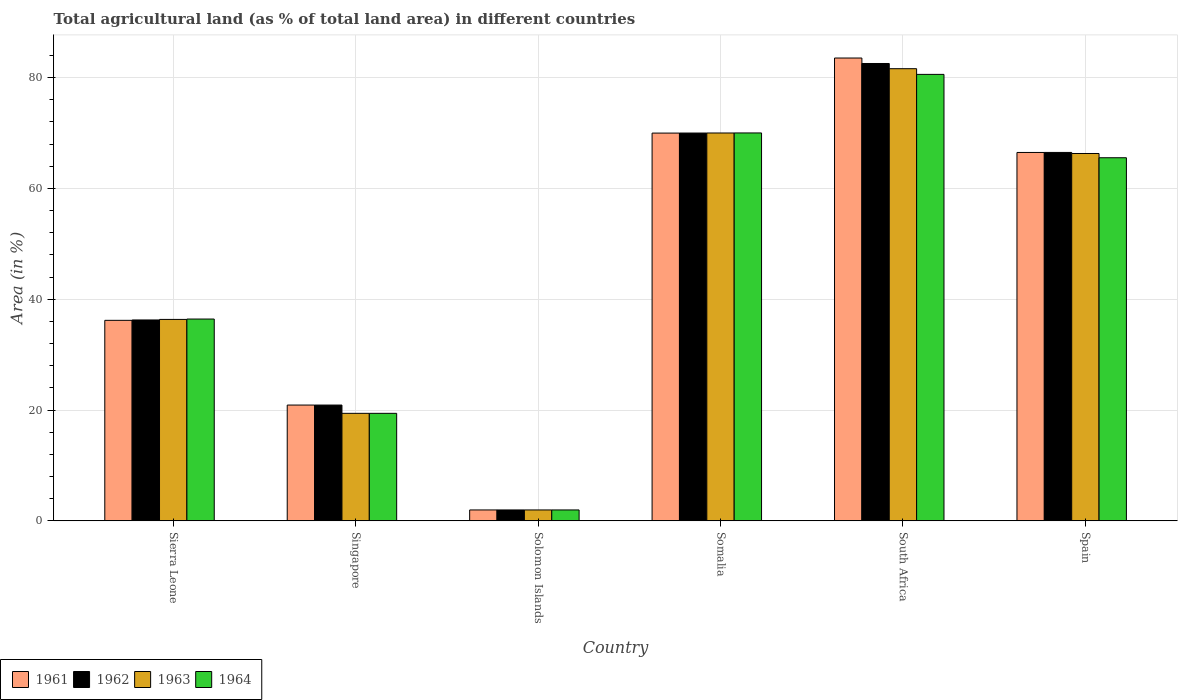How many different coloured bars are there?
Make the answer very short. 4. How many groups of bars are there?
Your answer should be very brief. 6. How many bars are there on the 4th tick from the left?
Provide a succinct answer. 4. How many bars are there on the 1st tick from the right?
Give a very brief answer. 4. What is the label of the 3rd group of bars from the left?
Your response must be concise. Solomon Islands. What is the percentage of agricultural land in 1964 in Singapore?
Give a very brief answer. 19.4. Across all countries, what is the maximum percentage of agricultural land in 1963?
Offer a terse response. 81.61. Across all countries, what is the minimum percentage of agricultural land in 1963?
Offer a terse response. 1.96. In which country was the percentage of agricultural land in 1964 maximum?
Offer a terse response. South Africa. In which country was the percentage of agricultural land in 1962 minimum?
Offer a very short reply. Solomon Islands. What is the total percentage of agricultural land in 1961 in the graph?
Provide a succinct answer. 279.06. What is the difference between the percentage of agricultural land in 1962 in Somalia and that in South Africa?
Offer a terse response. -12.55. What is the difference between the percentage of agricultural land in 1964 in South Africa and the percentage of agricultural land in 1962 in Sierra Leone?
Your response must be concise. 44.32. What is the average percentage of agricultural land in 1963 per country?
Your response must be concise. 45.94. In how many countries, is the percentage of agricultural land in 1964 greater than 48 %?
Your answer should be very brief. 3. What is the ratio of the percentage of agricultural land in 1962 in Sierra Leone to that in Solomon Islands?
Make the answer very short. 18.45. Is the percentage of agricultural land in 1964 in Sierra Leone less than that in South Africa?
Ensure brevity in your answer.  Yes. What is the difference between the highest and the second highest percentage of agricultural land in 1962?
Offer a terse response. 12.55. What is the difference between the highest and the lowest percentage of agricultural land in 1964?
Give a very brief answer. 78.61. In how many countries, is the percentage of agricultural land in 1962 greater than the average percentage of agricultural land in 1962 taken over all countries?
Offer a very short reply. 3. Is the sum of the percentage of agricultural land in 1963 in Singapore and South Africa greater than the maximum percentage of agricultural land in 1962 across all countries?
Give a very brief answer. Yes. Is it the case that in every country, the sum of the percentage of agricultural land in 1964 and percentage of agricultural land in 1963 is greater than the sum of percentage of agricultural land in 1961 and percentage of agricultural land in 1962?
Provide a short and direct response. No. What does the 3rd bar from the right in Somalia represents?
Your response must be concise. 1962. Is it the case that in every country, the sum of the percentage of agricultural land in 1961 and percentage of agricultural land in 1964 is greater than the percentage of agricultural land in 1963?
Give a very brief answer. Yes. How many bars are there?
Provide a succinct answer. 24. How many countries are there in the graph?
Make the answer very short. 6. Are the values on the major ticks of Y-axis written in scientific E-notation?
Keep it short and to the point. No. Does the graph contain any zero values?
Provide a succinct answer. No. Does the graph contain grids?
Your answer should be compact. Yes. Where does the legend appear in the graph?
Ensure brevity in your answer.  Bottom left. What is the title of the graph?
Offer a terse response. Total agricultural land (as % of total land area) in different countries. What is the label or title of the X-axis?
Ensure brevity in your answer.  Country. What is the label or title of the Y-axis?
Your answer should be compact. Area (in %). What is the Area (in %) in 1961 in Sierra Leone?
Provide a succinct answer. 36.19. What is the Area (in %) in 1962 in Sierra Leone?
Keep it short and to the point. 36.26. What is the Area (in %) in 1963 in Sierra Leone?
Keep it short and to the point. 36.35. What is the Area (in %) in 1964 in Sierra Leone?
Provide a succinct answer. 36.42. What is the Area (in %) in 1961 in Singapore?
Give a very brief answer. 20.9. What is the Area (in %) of 1962 in Singapore?
Your answer should be very brief. 20.9. What is the Area (in %) in 1963 in Singapore?
Make the answer very short. 19.4. What is the Area (in %) of 1964 in Singapore?
Keep it short and to the point. 19.4. What is the Area (in %) in 1961 in Solomon Islands?
Your answer should be very brief. 1.96. What is the Area (in %) in 1962 in Solomon Islands?
Offer a very short reply. 1.96. What is the Area (in %) in 1963 in Solomon Islands?
Ensure brevity in your answer.  1.96. What is the Area (in %) in 1964 in Solomon Islands?
Your response must be concise. 1.96. What is the Area (in %) in 1961 in Somalia?
Provide a short and direct response. 69.99. What is the Area (in %) of 1962 in Somalia?
Your answer should be compact. 69.99. What is the Area (in %) in 1963 in Somalia?
Your response must be concise. 70. What is the Area (in %) in 1964 in Somalia?
Provide a succinct answer. 70.01. What is the Area (in %) in 1961 in South Africa?
Give a very brief answer. 83.53. What is the Area (in %) in 1962 in South Africa?
Give a very brief answer. 82.55. What is the Area (in %) of 1963 in South Africa?
Make the answer very short. 81.61. What is the Area (in %) in 1964 in South Africa?
Give a very brief answer. 80.58. What is the Area (in %) of 1961 in Spain?
Offer a very short reply. 66.49. What is the Area (in %) of 1962 in Spain?
Offer a terse response. 66.49. What is the Area (in %) of 1963 in Spain?
Give a very brief answer. 66.3. What is the Area (in %) in 1964 in Spain?
Provide a succinct answer. 65.53. Across all countries, what is the maximum Area (in %) in 1961?
Your answer should be compact. 83.53. Across all countries, what is the maximum Area (in %) in 1962?
Make the answer very short. 82.55. Across all countries, what is the maximum Area (in %) in 1963?
Offer a terse response. 81.61. Across all countries, what is the maximum Area (in %) of 1964?
Make the answer very short. 80.58. Across all countries, what is the minimum Area (in %) of 1961?
Offer a terse response. 1.96. Across all countries, what is the minimum Area (in %) of 1962?
Your answer should be compact. 1.96. Across all countries, what is the minimum Area (in %) in 1963?
Provide a short and direct response. 1.96. Across all countries, what is the minimum Area (in %) of 1964?
Ensure brevity in your answer.  1.96. What is the total Area (in %) in 1961 in the graph?
Provide a short and direct response. 279.06. What is the total Area (in %) of 1962 in the graph?
Make the answer very short. 278.15. What is the total Area (in %) of 1963 in the graph?
Make the answer very short. 275.63. What is the total Area (in %) of 1964 in the graph?
Offer a terse response. 273.91. What is the difference between the Area (in %) in 1961 in Sierra Leone and that in Singapore?
Give a very brief answer. 15.29. What is the difference between the Area (in %) of 1962 in Sierra Leone and that in Singapore?
Your answer should be very brief. 15.36. What is the difference between the Area (in %) in 1963 in Sierra Leone and that in Singapore?
Your response must be concise. 16.95. What is the difference between the Area (in %) of 1964 in Sierra Leone and that in Singapore?
Your answer should be very brief. 17.02. What is the difference between the Area (in %) of 1961 in Sierra Leone and that in Solomon Islands?
Your answer should be very brief. 34.22. What is the difference between the Area (in %) of 1962 in Sierra Leone and that in Solomon Islands?
Your answer should be compact. 34.29. What is the difference between the Area (in %) of 1963 in Sierra Leone and that in Solomon Islands?
Your answer should be compact. 34.39. What is the difference between the Area (in %) in 1964 in Sierra Leone and that in Solomon Islands?
Make the answer very short. 34.46. What is the difference between the Area (in %) in 1961 in Sierra Leone and that in Somalia?
Make the answer very short. -33.8. What is the difference between the Area (in %) in 1962 in Sierra Leone and that in Somalia?
Your answer should be compact. -33.74. What is the difference between the Area (in %) in 1963 in Sierra Leone and that in Somalia?
Provide a succinct answer. -33.65. What is the difference between the Area (in %) of 1964 in Sierra Leone and that in Somalia?
Your answer should be compact. -33.59. What is the difference between the Area (in %) of 1961 in Sierra Leone and that in South Africa?
Offer a very short reply. -47.35. What is the difference between the Area (in %) in 1962 in Sierra Leone and that in South Africa?
Ensure brevity in your answer.  -46.29. What is the difference between the Area (in %) of 1963 in Sierra Leone and that in South Africa?
Offer a very short reply. -45.25. What is the difference between the Area (in %) in 1964 in Sierra Leone and that in South Africa?
Provide a short and direct response. -44.16. What is the difference between the Area (in %) of 1961 in Sierra Leone and that in Spain?
Provide a succinct answer. -30.3. What is the difference between the Area (in %) in 1962 in Sierra Leone and that in Spain?
Offer a terse response. -30.24. What is the difference between the Area (in %) of 1963 in Sierra Leone and that in Spain?
Give a very brief answer. -29.95. What is the difference between the Area (in %) of 1964 in Sierra Leone and that in Spain?
Provide a short and direct response. -29.11. What is the difference between the Area (in %) of 1961 in Singapore and that in Solomon Islands?
Your response must be concise. 18.93. What is the difference between the Area (in %) in 1962 in Singapore and that in Solomon Islands?
Offer a very short reply. 18.93. What is the difference between the Area (in %) of 1963 in Singapore and that in Solomon Islands?
Give a very brief answer. 17.44. What is the difference between the Area (in %) of 1964 in Singapore and that in Solomon Islands?
Make the answer very short. 17.44. What is the difference between the Area (in %) of 1961 in Singapore and that in Somalia?
Give a very brief answer. -49.09. What is the difference between the Area (in %) of 1962 in Singapore and that in Somalia?
Your answer should be compact. -49.1. What is the difference between the Area (in %) in 1963 in Singapore and that in Somalia?
Your answer should be compact. -50.6. What is the difference between the Area (in %) in 1964 in Singapore and that in Somalia?
Keep it short and to the point. -50.61. What is the difference between the Area (in %) of 1961 in Singapore and that in South Africa?
Your answer should be very brief. -62.64. What is the difference between the Area (in %) in 1962 in Singapore and that in South Africa?
Keep it short and to the point. -61.65. What is the difference between the Area (in %) in 1963 in Singapore and that in South Africa?
Your answer should be very brief. -62.2. What is the difference between the Area (in %) in 1964 in Singapore and that in South Africa?
Offer a terse response. -61.18. What is the difference between the Area (in %) of 1961 in Singapore and that in Spain?
Your answer should be very brief. -45.59. What is the difference between the Area (in %) of 1962 in Singapore and that in Spain?
Provide a succinct answer. -45.6. What is the difference between the Area (in %) in 1963 in Singapore and that in Spain?
Offer a terse response. -46.9. What is the difference between the Area (in %) in 1964 in Singapore and that in Spain?
Give a very brief answer. -46.13. What is the difference between the Area (in %) of 1961 in Solomon Islands and that in Somalia?
Your answer should be very brief. -68.02. What is the difference between the Area (in %) in 1962 in Solomon Islands and that in Somalia?
Your answer should be very brief. -68.03. What is the difference between the Area (in %) in 1963 in Solomon Islands and that in Somalia?
Give a very brief answer. -68.04. What is the difference between the Area (in %) in 1964 in Solomon Islands and that in Somalia?
Your response must be concise. -68.04. What is the difference between the Area (in %) of 1961 in Solomon Islands and that in South Africa?
Give a very brief answer. -81.57. What is the difference between the Area (in %) of 1962 in Solomon Islands and that in South Africa?
Give a very brief answer. -80.58. What is the difference between the Area (in %) in 1963 in Solomon Islands and that in South Africa?
Make the answer very short. -79.64. What is the difference between the Area (in %) of 1964 in Solomon Islands and that in South Africa?
Provide a short and direct response. -78.61. What is the difference between the Area (in %) in 1961 in Solomon Islands and that in Spain?
Provide a succinct answer. -64.52. What is the difference between the Area (in %) of 1962 in Solomon Islands and that in Spain?
Ensure brevity in your answer.  -64.53. What is the difference between the Area (in %) in 1963 in Solomon Islands and that in Spain?
Ensure brevity in your answer.  -64.34. What is the difference between the Area (in %) of 1964 in Solomon Islands and that in Spain?
Make the answer very short. -63.57. What is the difference between the Area (in %) of 1961 in Somalia and that in South Africa?
Your answer should be very brief. -13.55. What is the difference between the Area (in %) of 1962 in Somalia and that in South Africa?
Provide a succinct answer. -12.55. What is the difference between the Area (in %) of 1963 in Somalia and that in South Africa?
Offer a terse response. -11.6. What is the difference between the Area (in %) in 1964 in Somalia and that in South Africa?
Offer a very short reply. -10.57. What is the difference between the Area (in %) in 1961 in Somalia and that in Spain?
Ensure brevity in your answer.  3.5. What is the difference between the Area (in %) in 1962 in Somalia and that in Spain?
Offer a very short reply. 3.5. What is the difference between the Area (in %) in 1963 in Somalia and that in Spain?
Your answer should be very brief. 3.7. What is the difference between the Area (in %) in 1964 in Somalia and that in Spain?
Offer a very short reply. 4.47. What is the difference between the Area (in %) in 1961 in South Africa and that in Spain?
Provide a succinct answer. 17.05. What is the difference between the Area (in %) in 1962 in South Africa and that in Spain?
Make the answer very short. 16.05. What is the difference between the Area (in %) in 1963 in South Africa and that in Spain?
Make the answer very short. 15.3. What is the difference between the Area (in %) of 1964 in South Africa and that in Spain?
Keep it short and to the point. 15.04. What is the difference between the Area (in %) of 1961 in Sierra Leone and the Area (in %) of 1962 in Singapore?
Provide a succinct answer. 15.29. What is the difference between the Area (in %) in 1961 in Sierra Leone and the Area (in %) in 1963 in Singapore?
Provide a short and direct response. 16.78. What is the difference between the Area (in %) of 1961 in Sierra Leone and the Area (in %) of 1964 in Singapore?
Keep it short and to the point. 16.78. What is the difference between the Area (in %) of 1962 in Sierra Leone and the Area (in %) of 1963 in Singapore?
Ensure brevity in your answer.  16.85. What is the difference between the Area (in %) in 1962 in Sierra Leone and the Area (in %) in 1964 in Singapore?
Provide a succinct answer. 16.85. What is the difference between the Area (in %) in 1963 in Sierra Leone and the Area (in %) in 1964 in Singapore?
Give a very brief answer. 16.95. What is the difference between the Area (in %) of 1961 in Sierra Leone and the Area (in %) of 1962 in Solomon Islands?
Offer a very short reply. 34.22. What is the difference between the Area (in %) in 1961 in Sierra Leone and the Area (in %) in 1963 in Solomon Islands?
Keep it short and to the point. 34.22. What is the difference between the Area (in %) in 1961 in Sierra Leone and the Area (in %) in 1964 in Solomon Islands?
Give a very brief answer. 34.22. What is the difference between the Area (in %) in 1962 in Sierra Leone and the Area (in %) in 1963 in Solomon Islands?
Keep it short and to the point. 34.29. What is the difference between the Area (in %) in 1962 in Sierra Leone and the Area (in %) in 1964 in Solomon Islands?
Offer a very short reply. 34.29. What is the difference between the Area (in %) in 1963 in Sierra Leone and the Area (in %) in 1964 in Solomon Islands?
Make the answer very short. 34.39. What is the difference between the Area (in %) of 1961 in Sierra Leone and the Area (in %) of 1962 in Somalia?
Give a very brief answer. -33.81. What is the difference between the Area (in %) in 1961 in Sierra Leone and the Area (in %) in 1963 in Somalia?
Make the answer very short. -33.81. What is the difference between the Area (in %) in 1961 in Sierra Leone and the Area (in %) in 1964 in Somalia?
Provide a succinct answer. -33.82. What is the difference between the Area (in %) of 1962 in Sierra Leone and the Area (in %) of 1963 in Somalia?
Provide a succinct answer. -33.75. What is the difference between the Area (in %) of 1962 in Sierra Leone and the Area (in %) of 1964 in Somalia?
Give a very brief answer. -33.75. What is the difference between the Area (in %) of 1963 in Sierra Leone and the Area (in %) of 1964 in Somalia?
Provide a succinct answer. -33.66. What is the difference between the Area (in %) of 1961 in Sierra Leone and the Area (in %) of 1962 in South Africa?
Give a very brief answer. -46.36. What is the difference between the Area (in %) of 1961 in Sierra Leone and the Area (in %) of 1963 in South Africa?
Offer a terse response. -45.42. What is the difference between the Area (in %) of 1961 in Sierra Leone and the Area (in %) of 1964 in South Africa?
Your answer should be compact. -44.39. What is the difference between the Area (in %) of 1962 in Sierra Leone and the Area (in %) of 1963 in South Africa?
Your answer should be very brief. -45.35. What is the difference between the Area (in %) in 1962 in Sierra Leone and the Area (in %) in 1964 in South Africa?
Your answer should be compact. -44.32. What is the difference between the Area (in %) of 1963 in Sierra Leone and the Area (in %) of 1964 in South Africa?
Offer a very short reply. -44.23. What is the difference between the Area (in %) of 1961 in Sierra Leone and the Area (in %) of 1962 in Spain?
Provide a short and direct response. -30.31. What is the difference between the Area (in %) in 1961 in Sierra Leone and the Area (in %) in 1963 in Spain?
Provide a short and direct response. -30.12. What is the difference between the Area (in %) in 1961 in Sierra Leone and the Area (in %) in 1964 in Spain?
Offer a very short reply. -29.35. What is the difference between the Area (in %) in 1962 in Sierra Leone and the Area (in %) in 1963 in Spain?
Offer a very short reply. -30.05. What is the difference between the Area (in %) of 1962 in Sierra Leone and the Area (in %) of 1964 in Spain?
Your answer should be very brief. -29.28. What is the difference between the Area (in %) in 1963 in Sierra Leone and the Area (in %) in 1964 in Spain?
Offer a very short reply. -29.18. What is the difference between the Area (in %) in 1961 in Singapore and the Area (in %) in 1962 in Solomon Islands?
Provide a short and direct response. 18.93. What is the difference between the Area (in %) of 1961 in Singapore and the Area (in %) of 1963 in Solomon Islands?
Your answer should be compact. 18.93. What is the difference between the Area (in %) of 1961 in Singapore and the Area (in %) of 1964 in Solomon Islands?
Make the answer very short. 18.93. What is the difference between the Area (in %) of 1962 in Singapore and the Area (in %) of 1963 in Solomon Islands?
Your response must be concise. 18.93. What is the difference between the Area (in %) of 1962 in Singapore and the Area (in %) of 1964 in Solomon Islands?
Keep it short and to the point. 18.93. What is the difference between the Area (in %) in 1963 in Singapore and the Area (in %) in 1964 in Solomon Islands?
Provide a succinct answer. 17.44. What is the difference between the Area (in %) in 1961 in Singapore and the Area (in %) in 1962 in Somalia?
Provide a short and direct response. -49.1. What is the difference between the Area (in %) of 1961 in Singapore and the Area (in %) of 1963 in Somalia?
Ensure brevity in your answer.  -49.11. What is the difference between the Area (in %) in 1961 in Singapore and the Area (in %) in 1964 in Somalia?
Provide a short and direct response. -49.11. What is the difference between the Area (in %) of 1962 in Singapore and the Area (in %) of 1963 in Somalia?
Offer a very short reply. -49.11. What is the difference between the Area (in %) of 1962 in Singapore and the Area (in %) of 1964 in Somalia?
Your response must be concise. -49.11. What is the difference between the Area (in %) of 1963 in Singapore and the Area (in %) of 1964 in Somalia?
Offer a very short reply. -50.61. What is the difference between the Area (in %) of 1961 in Singapore and the Area (in %) of 1962 in South Africa?
Provide a succinct answer. -61.65. What is the difference between the Area (in %) of 1961 in Singapore and the Area (in %) of 1963 in South Africa?
Provide a short and direct response. -60.71. What is the difference between the Area (in %) in 1961 in Singapore and the Area (in %) in 1964 in South Africa?
Provide a succinct answer. -59.68. What is the difference between the Area (in %) in 1962 in Singapore and the Area (in %) in 1963 in South Africa?
Provide a short and direct response. -60.71. What is the difference between the Area (in %) of 1962 in Singapore and the Area (in %) of 1964 in South Africa?
Ensure brevity in your answer.  -59.68. What is the difference between the Area (in %) of 1963 in Singapore and the Area (in %) of 1964 in South Africa?
Ensure brevity in your answer.  -61.18. What is the difference between the Area (in %) of 1961 in Singapore and the Area (in %) of 1962 in Spain?
Offer a terse response. -45.6. What is the difference between the Area (in %) in 1961 in Singapore and the Area (in %) in 1963 in Spain?
Offer a terse response. -45.41. What is the difference between the Area (in %) in 1961 in Singapore and the Area (in %) in 1964 in Spain?
Provide a short and direct response. -44.64. What is the difference between the Area (in %) of 1962 in Singapore and the Area (in %) of 1963 in Spain?
Make the answer very short. -45.41. What is the difference between the Area (in %) in 1962 in Singapore and the Area (in %) in 1964 in Spain?
Offer a terse response. -44.64. What is the difference between the Area (in %) in 1963 in Singapore and the Area (in %) in 1964 in Spain?
Keep it short and to the point. -46.13. What is the difference between the Area (in %) of 1961 in Solomon Islands and the Area (in %) of 1962 in Somalia?
Offer a very short reply. -68.03. What is the difference between the Area (in %) in 1961 in Solomon Islands and the Area (in %) in 1963 in Somalia?
Ensure brevity in your answer.  -68.04. What is the difference between the Area (in %) in 1961 in Solomon Islands and the Area (in %) in 1964 in Somalia?
Your answer should be very brief. -68.04. What is the difference between the Area (in %) in 1962 in Solomon Islands and the Area (in %) in 1963 in Somalia?
Your response must be concise. -68.04. What is the difference between the Area (in %) in 1962 in Solomon Islands and the Area (in %) in 1964 in Somalia?
Ensure brevity in your answer.  -68.04. What is the difference between the Area (in %) of 1963 in Solomon Islands and the Area (in %) of 1964 in Somalia?
Provide a succinct answer. -68.04. What is the difference between the Area (in %) in 1961 in Solomon Islands and the Area (in %) in 1962 in South Africa?
Make the answer very short. -80.58. What is the difference between the Area (in %) of 1961 in Solomon Islands and the Area (in %) of 1963 in South Africa?
Keep it short and to the point. -79.64. What is the difference between the Area (in %) of 1961 in Solomon Islands and the Area (in %) of 1964 in South Africa?
Keep it short and to the point. -78.61. What is the difference between the Area (in %) of 1962 in Solomon Islands and the Area (in %) of 1963 in South Africa?
Offer a terse response. -79.64. What is the difference between the Area (in %) of 1962 in Solomon Islands and the Area (in %) of 1964 in South Africa?
Offer a very short reply. -78.61. What is the difference between the Area (in %) of 1963 in Solomon Islands and the Area (in %) of 1964 in South Africa?
Your answer should be compact. -78.61. What is the difference between the Area (in %) of 1961 in Solomon Islands and the Area (in %) of 1962 in Spain?
Keep it short and to the point. -64.53. What is the difference between the Area (in %) of 1961 in Solomon Islands and the Area (in %) of 1963 in Spain?
Your response must be concise. -64.34. What is the difference between the Area (in %) in 1961 in Solomon Islands and the Area (in %) in 1964 in Spain?
Your answer should be very brief. -63.57. What is the difference between the Area (in %) in 1962 in Solomon Islands and the Area (in %) in 1963 in Spain?
Offer a very short reply. -64.34. What is the difference between the Area (in %) in 1962 in Solomon Islands and the Area (in %) in 1964 in Spain?
Keep it short and to the point. -63.57. What is the difference between the Area (in %) in 1963 in Solomon Islands and the Area (in %) in 1964 in Spain?
Offer a terse response. -63.57. What is the difference between the Area (in %) of 1961 in Somalia and the Area (in %) of 1962 in South Africa?
Your answer should be compact. -12.56. What is the difference between the Area (in %) in 1961 in Somalia and the Area (in %) in 1963 in South Africa?
Make the answer very short. -11.62. What is the difference between the Area (in %) in 1961 in Somalia and the Area (in %) in 1964 in South Africa?
Make the answer very short. -10.59. What is the difference between the Area (in %) in 1962 in Somalia and the Area (in %) in 1963 in South Africa?
Provide a short and direct response. -11.61. What is the difference between the Area (in %) in 1962 in Somalia and the Area (in %) in 1964 in South Africa?
Your response must be concise. -10.59. What is the difference between the Area (in %) in 1963 in Somalia and the Area (in %) in 1964 in South Africa?
Ensure brevity in your answer.  -10.58. What is the difference between the Area (in %) of 1961 in Somalia and the Area (in %) of 1962 in Spain?
Provide a succinct answer. 3.49. What is the difference between the Area (in %) of 1961 in Somalia and the Area (in %) of 1963 in Spain?
Make the answer very short. 3.68. What is the difference between the Area (in %) in 1961 in Somalia and the Area (in %) in 1964 in Spain?
Give a very brief answer. 4.45. What is the difference between the Area (in %) of 1962 in Somalia and the Area (in %) of 1963 in Spain?
Give a very brief answer. 3.69. What is the difference between the Area (in %) of 1962 in Somalia and the Area (in %) of 1964 in Spain?
Give a very brief answer. 4.46. What is the difference between the Area (in %) in 1963 in Somalia and the Area (in %) in 1964 in Spain?
Offer a terse response. 4.47. What is the difference between the Area (in %) in 1961 in South Africa and the Area (in %) in 1962 in Spain?
Provide a short and direct response. 17.04. What is the difference between the Area (in %) of 1961 in South Africa and the Area (in %) of 1963 in Spain?
Offer a very short reply. 17.23. What is the difference between the Area (in %) in 1961 in South Africa and the Area (in %) in 1964 in Spain?
Your response must be concise. 18. What is the difference between the Area (in %) of 1962 in South Africa and the Area (in %) of 1963 in Spain?
Give a very brief answer. 16.24. What is the difference between the Area (in %) of 1962 in South Africa and the Area (in %) of 1964 in Spain?
Ensure brevity in your answer.  17.01. What is the difference between the Area (in %) of 1963 in South Africa and the Area (in %) of 1964 in Spain?
Your response must be concise. 16.07. What is the average Area (in %) in 1961 per country?
Make the answer very short. 46.51. What is the average Area (in %) of 1962 per country?
Provide a short and direct response. 46.36. What is the average Area (in %) of 1963 per country?
Your response must be concise. 45.94. What is the average Area (in %) in 1964 per country?
Give a very brief answer. 45.65. What is the difference between the Area (in %) of 1961 and Area (in %) of 1962 in Sierra Leone?
Provide a succinct answer. -0.07. What is the difference between the Area (in %) of 1961 and Area (in %) of 1963 in Sierra Leone?
Your answer should be very brief. -0.17. What is the difference between the Area (in %) in 1961 and Area (in %) in 1964 in Sierra Leone?
Ensure brevity in your answer.  -0.24. What is the difference between the Area (in %) of 1962 and Area (in %) of 1963 in Sierra Leone?
Offer a very short reply. -0.1. What is the difference between the Area (in %) in 1962 and Area (in %) in 1964 in Sierra Leone?
Offer a terse response. -0.17. What is the difference between the Area (in %) of 1963 and Area (in %) of 1964 in Sierra Leone?
Make the answer very short. -0.07. What is the difference between the Area (in %) in 1961 and Area (in %) in 1962 in Singapore?
Keep it short and to the point. 0. What is the difference between the Area (in %) in 1961 and Area (in %) in 1963 in Singapore?
Ensure brevity in your answer.  1.49. What is the difference between the Area (in %) of 1961 and Area (in %) of 1964 in Singapore?
Ensure brevity in your answer.  1.49. What is the difference between the Area (in %) of 1962 and Area (in %) of 1963 in Singapore?
Your answer should be very brief. 1.49. What is the difference between the Area (in %) in 1962 and Area (in %) in 1964 in Singapore?
Provide a succinct answer. 1.49. What is the difference between the Area (in %) of 1963 and Area (in %) of 1964 in Singapore?
Your response must be concise. 0. What is the difference between the Area (in %) of 1961 and Area (in %) of 1962 in Somalia?
Offer a terse response. -0.01. What is the difference between the Area (in %) of 1961 and Area (in %) of 1963 in Somalia?
Offer a very short reply. -0.02. What is the difference between the Area (in %) in 1961 and Area (in %) in 1964 in Somalia?
Your response must be concise. -0.02. What is the difference between the Area (in %) of 1962 and Area (in %) of 1963 in Somalia?
Provide a succinct answer. -0.01. What is the difference between the Area (in %) in 1962 and Area (in %) in 1964 in Somalia?
Give a very brief answer. -0.02. What is the difference between the Area (in %) in 1963 and Area (in %) in 1964 in Somalia?
Your response must be concise. -0.01. What is the difference between the Area (in %) in 1961 and Area (in %) in 1963 in South Africa?
Your answer should be compact. 1.93. What is the difference between the Area (in %) of 1961 and Area (in %) of 1964 in South Africa?
Offer a very short reply. 2.96. What is the difference between the Area (in %) in 1962 and Area (in %) in 1963 in South Africa?
Give a very brief answer. 0.94. What is the difference between the Area (in %) in 1962 and Area (in %) in 1964 in South Africa?
Your answer should be very brief. 1.97. What is the difference between the Area (in %) of 1963 and Area (in %) of 1964 in South Africa?
Provide a succinct answer. 1.03. What is the difference between the Area (in %) in 1961 and Area (in %) in 1962 in Spain?
Your response must be concise. -0. What is the difference between the Area (in %) in 1961 and Area (in %) in 1963 in Spain?
Give a very brief answer. 0.19. What is the difference between the Area (in %) of 1961 and Area (in %) of 1964 in Spain?
Give a very brief answer. 0.95. What is the difference between the Area (in %) of 1962 and Area (in %) of 1963 in Spain?
Offer a very short reply. 0.19. What is the difference between the Area (in %) of 1962 and Area (in %) of 1964 in Spain?
Provide a succinct answer. 0.96. What is the difference between the Area (in %) in 1963 and Area (in %) in 1964 in Spain?
Offer a very short reply. 0.77. What is the ratio of the Area (in %) in 1961 in Sierra Leone to that in Singapore?
Provide a short and direct response. 1.73. What is the ratio of the Area (in %) of 1962 in Sierra Leone to that in Singapore?
Offer a very short reply. 1.74. What is the ratio of the Area (in %) in 1963 in Sierra Leone to that in Singapore?
Make the answer very short. 1.87. What is the ratio of the Area (in %) in 1964 in Sierra Leone to that in Singapore?
Ensure brevity in your answer.  1.88. What is the ratio of the Area (in %) in 1961 in Sierra Leone to that in Solomon Islands?
Your answer should be compact. 18.42. What is the ratio of the Area (in %) in 1962 in Sierra Leone to that in Solomon Islands?
Provide a short and direct response. 18.45. What is the ratio of the Area (in %) of 1963 in Sierra Leone to that in Solomon Islands?
Provide a short and direct response. 18.5. What is the ratio of the Area (in %) of 1964 in Sierra Leone to that in Solomon Islands?
Your answer should be very brief. 18.54. What is the ratio of the Area (in %) of 1961 in Sierra Leone to that in Somalia?
Give a very brief answer. 0.52. What is the ratio of the Area (in %) of 1962 in Sierra Leone to that in Somalia?
Your response must be concise. 0.52. What is the ratio of the Area (in %) of 1963 in Sierra Leone to that in Somalia?
Offer a very short reply. 0.52. What is the ratio of the Area (in %) of 1964 in Sierra Leone to that in Somalia?
Make the answer very short. 0.52. What is the ratio of the Area (in %) of 1961 in Sierra Leone to that in South Africa?
Provide a succinct answer. 0.43. What is the ratio of the Area (in %) of 1962 in Sierra Leone to that in South Africa?
Offer a terse response. 0.44. What is the ratio of the Area (in %) in 1963 in Sierra Leone to that in South Africa?
Provide a succinct answer. 0.45. What is the ratio of the Area (in %) of 1964 in Sierra Leone to that in South Africa?
Offer a very short reply. 0.45. What is the ratio of the Area (in %) of 1961 in Sierra Leone to that in Spain?
Provide a succinct answer. 0.54. What is the ratio of the Area (in %) in 1962 in Sierra Leone to that in Spain?
Ensure brevity in your answer.  0.55. What is the ratio of the Area (in %) of 1963 in Sierra Leone to that in Spain?
Ensure brevity in your answer.  0.55. What is the ratio of the Area (in %) of 1964 in Sierra Leone to that in Spain?
Provide a succinct answer. 0.56. What is the ratio of the Area (in %) in 1961 in Singapore to that in Solomon Islands?
Keep it short and to the point. 10.63. What is the ratio of the Area (in %) of 1962 in Singapore to that in Solomon Islands?
Give a very brief answer. 10.63. What is the ratio of the Area (in %) in 1963 in Singapore to that in Solomon Islands?
Give a very brief answer. 9.87. What is the ratio of the Area (in %) of 1964 in Singapore to that in Solomon Islands?
Keep it short and to the point. 9.87. What is the ratio of the Area (in %) of 1961 in Singapore to that in Somalia?
Offer a terse response. 0.3. What is the ratio of the Area (in %) of 1962 in Singapore to that in Somalia?
Provide a short and direct response. 0.3. What is the ratio of the Area (in %) in 1963 in Singapore to that in Somalia?
Provide a succinct answer. 0.28. What is the ratio of the Area (in %) of 1964 in Singapore to that in Somalia?
Offer a very short reply. 0.28. What is the ratio of the Area (in %) in 1961 in Singapore to that in South Africa?
Ensure brevity in your answer.  0.25. What is the ratio of the Area (in %) in 1962 in Singapore to that in South Africa?
Your response must be concise. 0.25. What is the ratio of the Area (in %) of 1963 in Singapore to that in South Africa?
Your answer should be compact. 0.24. What is the ratio of the Area (in %) in 1964 in Singapore to that in South Africa?
Make the answer very short. 0.24. What is the ratio of the Area (in %) in 1961 in Singapore to that in Spain?
Offer a terse response. 0.31. What is the ratio of the Area (in %) of 1962 in Singapore to that in Spain?
Offer a very short reply. 0.31. What is the ratio of the Area (in %) of 1963 in Singapore to that in Spain?
Offer a terse response. 0.29. What is the ratio of the Area (in %) of 1964 in Singapore to that in Spain?
Offer a very short reply. 0.3. What is the ratio of the Area (in %) in 1961 in Solomon Islands to that in Somalia?
Ensure brevity in your answer.  0.03. What is the ratio of the Area (in %) of 1962 in Solomon Islands to that in Somalia?
Offer a terse response. 0.03. What is the ratio of the Area (in %) of 1963 in Solomon Islands to that in Somalia?
Make the answer very short. 0.03. What is the ratio of the Area (in %) of 1964 in Solomon Islands to that in Somalia?
Your answer should be very brief. 0.03. What is the ratio of the Area (in %) of 1961 in Solomon Islands to that in South Africa?
Offer a very short reply. 0.02. What is the ratio of the Area (in %) in 1962 in Solomon Islands to that in South Africa?
Offer a very short reply. 0.02. What is the ratio of the Area (in %) in 1963 in Solomon Islands to that in South Africa?
Ensure brevity in your answer.  0.02. What is the ratio of the Area (in %) of 1964 in Solomon Islands to that in South Africa?
Offer a very short reply. 0.02. What is the ratio of the Area (in %) in 1961 in Solomon Islands to that in Spain?
Provide a succinct answer. 0.03. What is the ratio of the Area (in %) of 1962 in Solomon Islands to that in Spain?
Offer a terse response. 0.03. What is the ratio of the Area (in %) of 1963 in Solomon Islands to that in Spain?
Offer a very short reply. 0.03. What is the ratio of the Area (in %) in 1961 in Somalia to that in South Africa?
Give a very brief answer. 0.84. What is the ratio of the Area (in %) in 1962 in Somalia to that in South Africa?
Your response must be concise. 0.85. What is the ratio of the Area (in %) of 1963 in Somalia to that in South Africa?
Keep it short and to the point. 0.86. What is the ratio of the Area (in %) of 1964 in Somalia to that in South Africa?
Your answer should be compact. 0.87. What is the ratio of the Area (in %) in 1961 in Somalia to that in Spain?
Make the answer very short. 1.05. What is the ratio of the Area (in %) of 1962 in Somalia to that in Spain?
Your response must be concise. 1.05. What is the ratio of the Area (in %) of 1963 in Somalia to that in Spain?
Your answer should be very brief. 1.06. What is the ratio of the Area (in %) in 1964 in Somalia to that in Spain?
Ensure brevity in your answer.  1.07. What is the ratio of the Area (in %) in 1961 in South Africa to that in Spain?
Give a very brief answer. 1.26. What is the ratio of the Area (in %) in 1962 in South Africa to that in Spain?
Give a very brief answer. 1.24. What is the ratio of the Area (in %) in 1963 in South Africa to that in Spain?
Your answer should be compact. 1.23. What is the ratio of the Area (in %) of 1964 in South Africa to that in Spain?
Make the answer very short. 1.23. What is the difference between the highest and the second highest Area (in %) in 1961?
Provide a short and direct response. 13.55. What is the difference between the highest and the second highest Area (in %) in 1962?
Provide a short and direct response. 12.55. What is the difference between the highest and the second highest Area (in %) in 1963?
Make the answer very short. 11.6. What is the difference between the highest and the second highest Area (in %) in 1964?
Your answer should be compact. 10.57. What is the difference between the highest and the lowest Area (in %) of 1961?
Make the answer very short. 81.57. What is the difference between the highest and the lowest Area (in %) of 1962?
Provide a succinct answer. 80.58. What is the difference between the highest and the lowest Area (in %) of 1963?
Your answer should be compact. 79.64. What is the difference between the highest and the lowest Area (in %) in 1964?
Give a very brief answer. 78.61. 